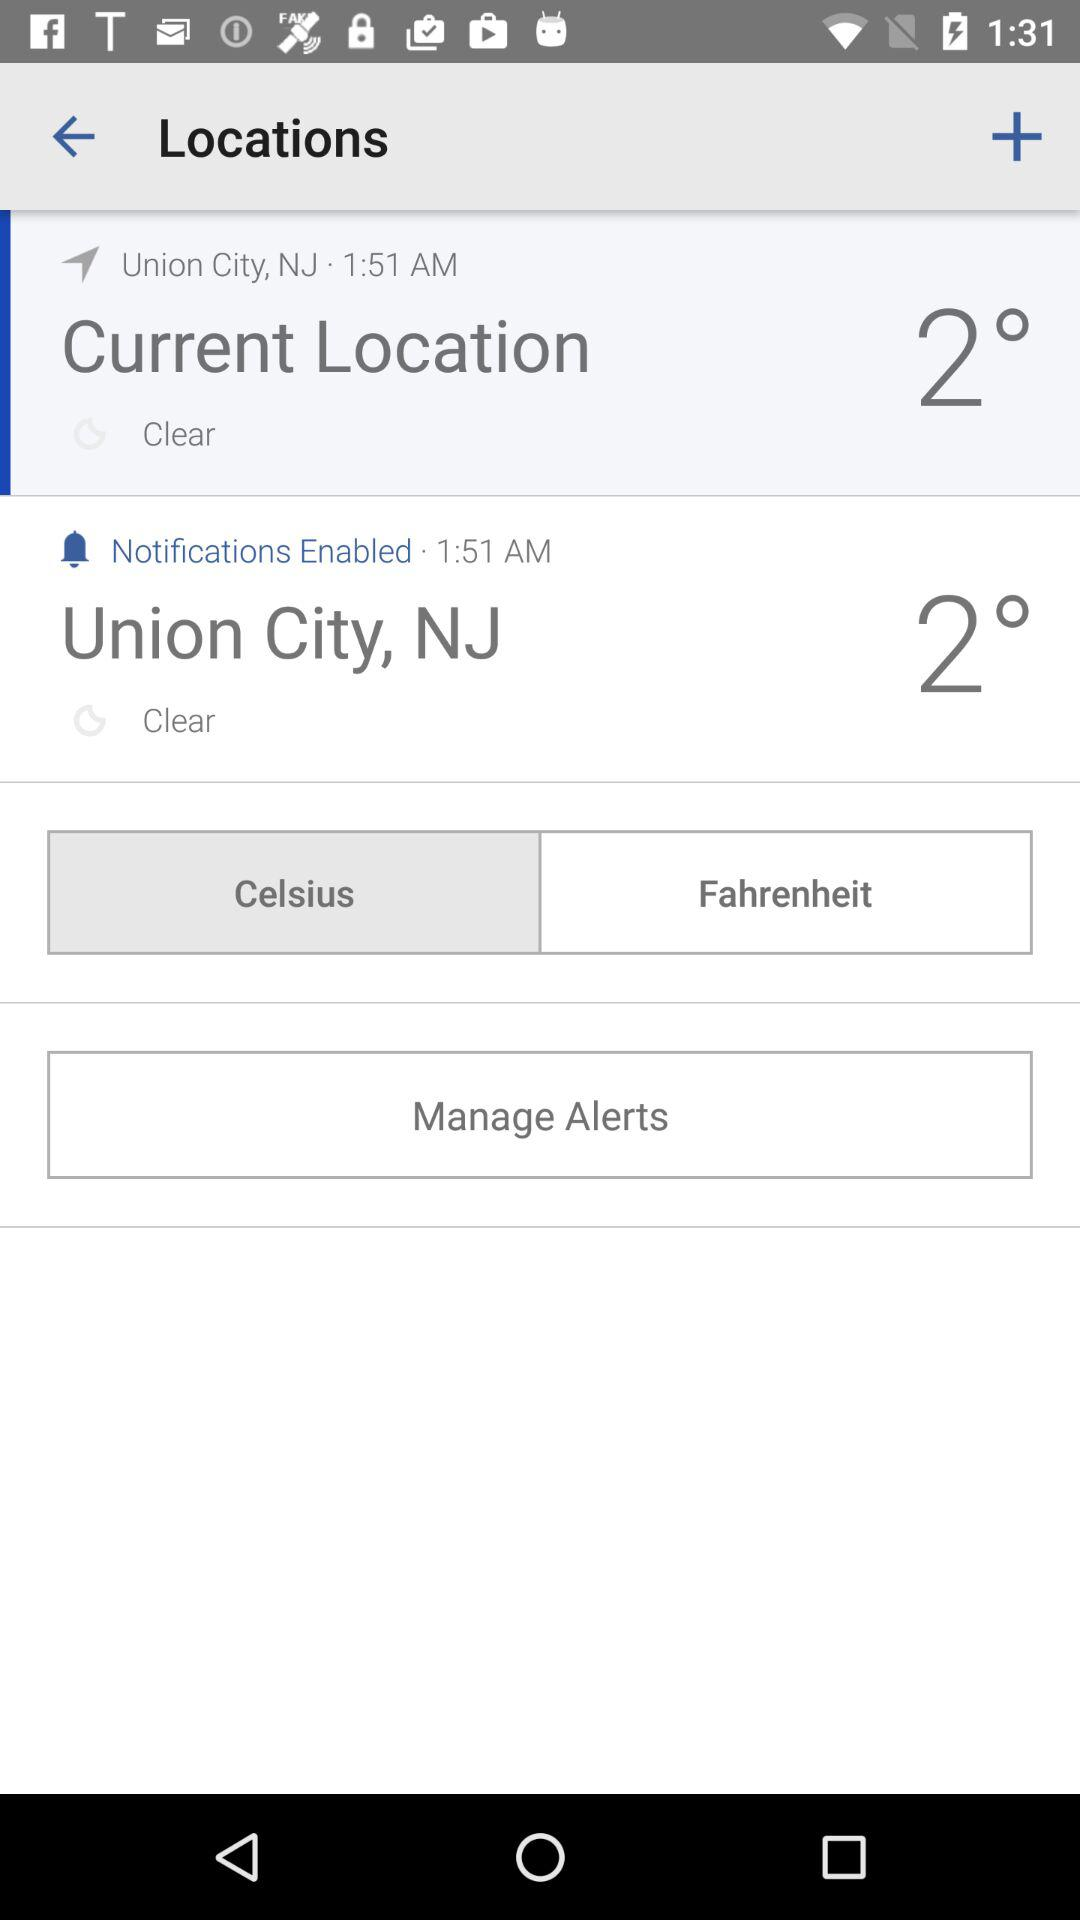What is the shown time? The shown time is 1:51 AM. 